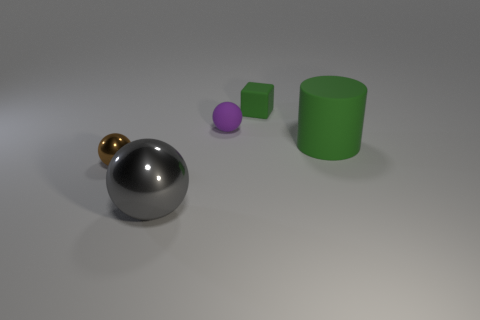Could you tell me what the lighting in the scene suggests about the setting? The lighting in the scene is diffused and comes from above, creating soft shadows beneath the objects. There are no harsh shadows or bright hotspots, which means the light source is not directly exposed. This type of lighting is indicative of an indoor setting where the light might be bouncing off walls or being diffused through a medium, providing a controlled environment typically used in studio photography or 3D renderings. 